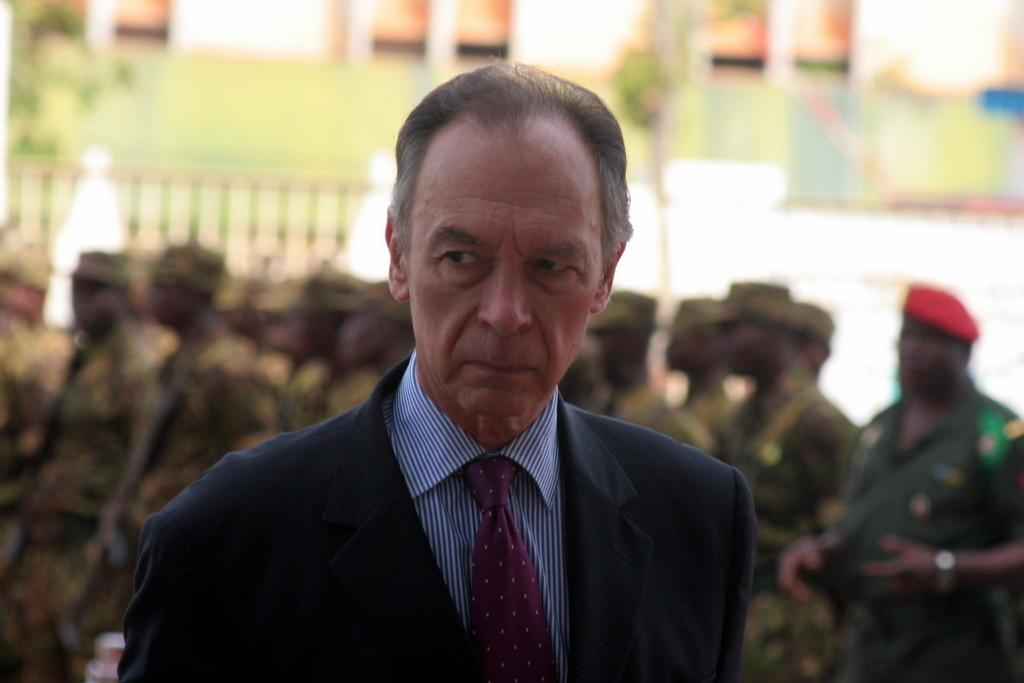Who is present in the image? There is a man in the image. What is the man wearing? The man is wearing a suit. What can be seen in the background of the image? There are army personnel in the background of the image. How would you describe the background of the image? The background of the image appears blurry. What type of hose is being used by the man in the image? There is no hose present in the image. What game are the army personnel playing in the background? There is no indication of a game being played in the image; the army personnel are simply present in the background. 